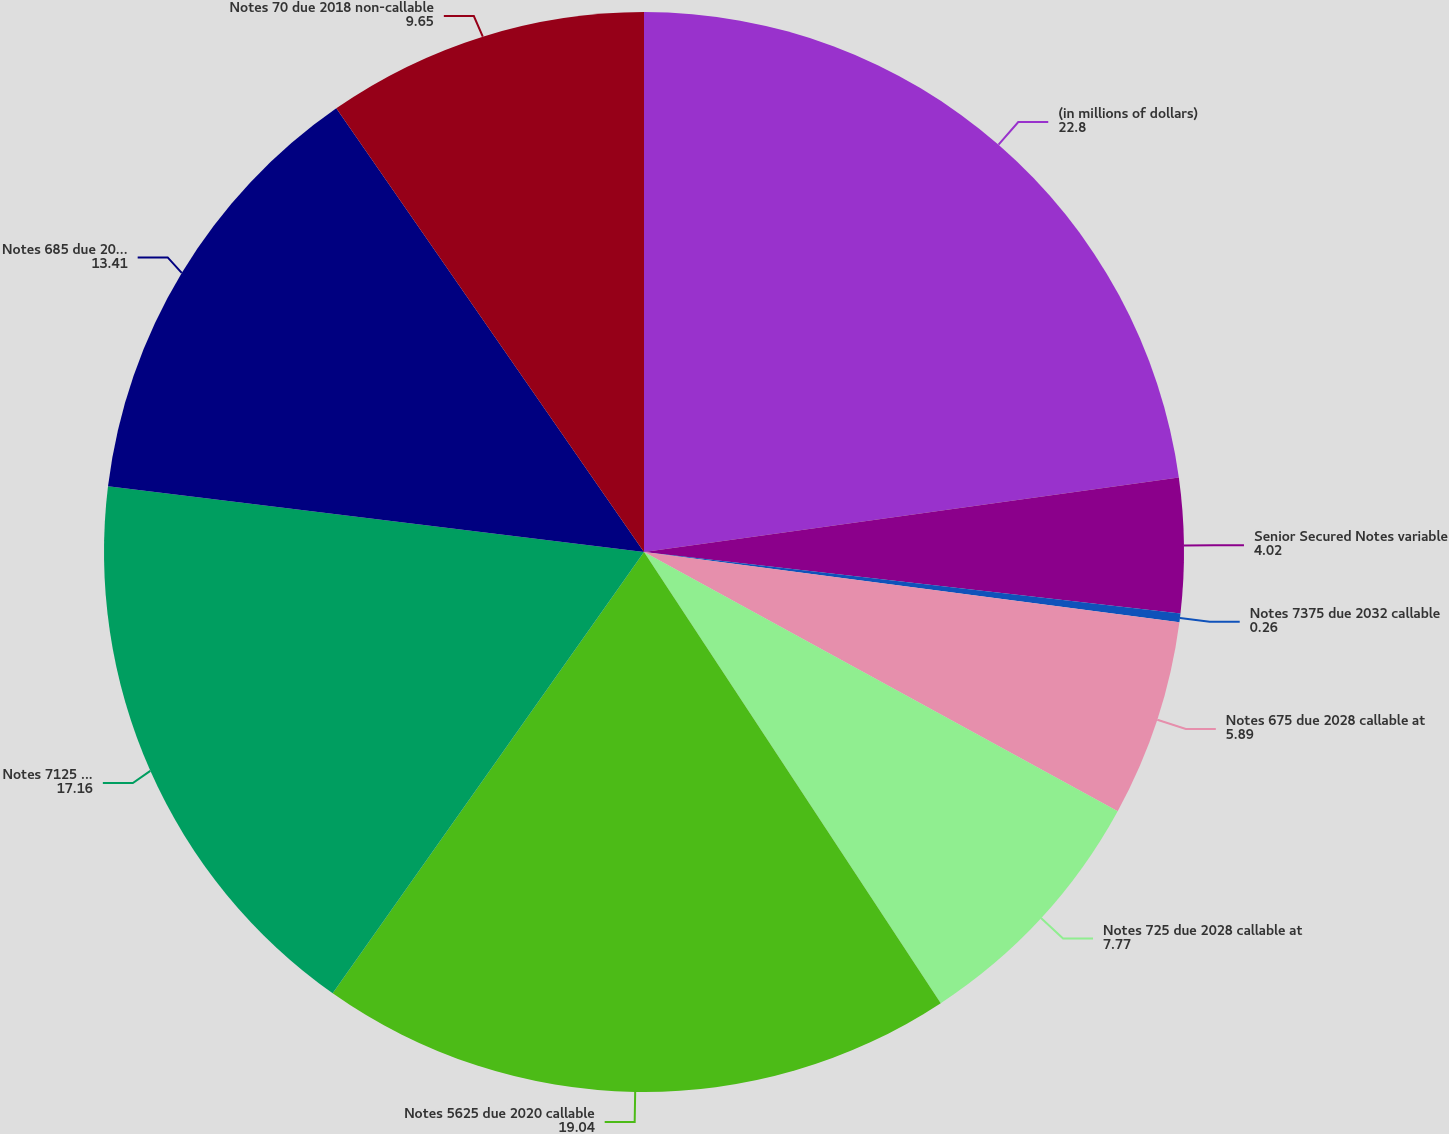Convert chart. <chart><loc_0><loc_0><loc_500><loc_500><pie_chart><fcel>(in millions of dollars)<fcel>Senior Secured Notes variable<fcel>Notes 7375 due 2032 callable<fcel>Notes 675 due 2028 callable at<fcel>Notes 725 due 2028 callable at<fcel>Notes 5625 due 2020 callable<fcel>Notes 7125 due 2016 callable<fcel>Notes 685 due 2015 callable at<fcel>Notes 70 due 2018 non-callable<nl><fcel>22.8%<fcel>4.02%<fcel>0.26%<fcel>5.89%<fcel>7.77%<fcel>19.04%<fcel>17.16%<fcel>13.41%<fcel>9.65%<nl></chart> 